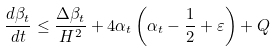Convert formula to latex. <formula><loc_0><loc_0><loc_500><loc_500>\frac { d \beta _ { t } } { d t } \leq \frac { \Delta \beta _ { t } } { H ^ { 2 } } + 4 \alpha _ { t } \left ( \alpha _ { t } - \frac { 1 } { 2 } + \varepsilon \right ) + Q</formula> 